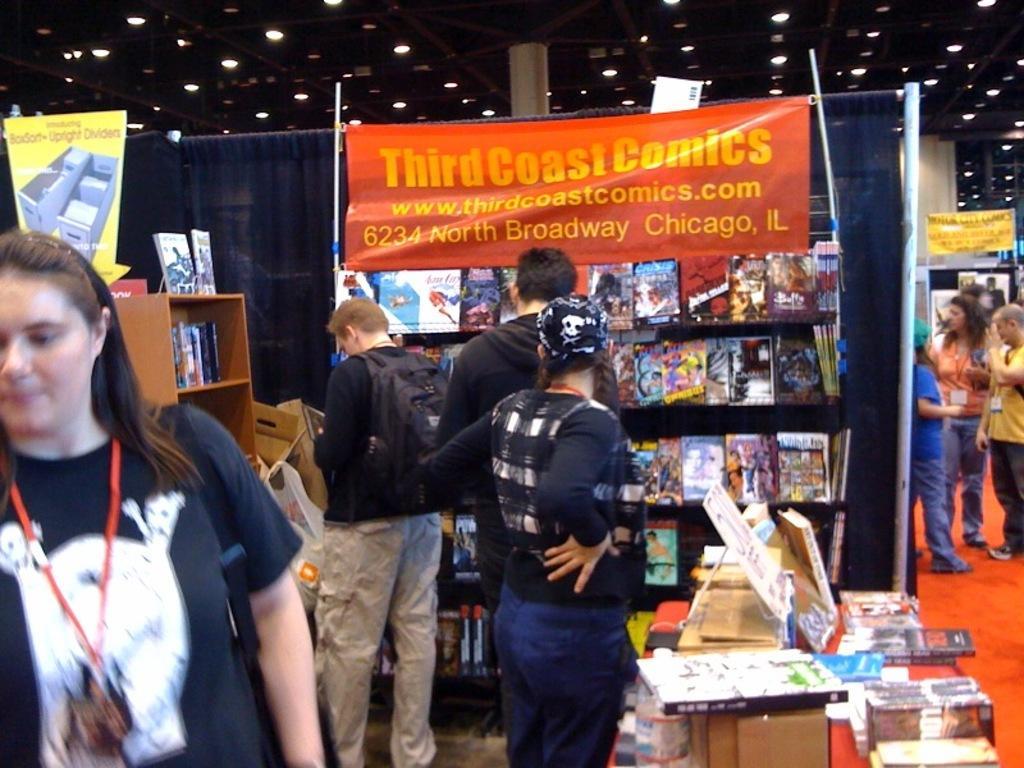Could you give a brief overview of what you see in this image? This image is clicked in a exhibition, in the front there are few people standing in front of book racks, the floor is of red color, over the ceiling there are lights. 